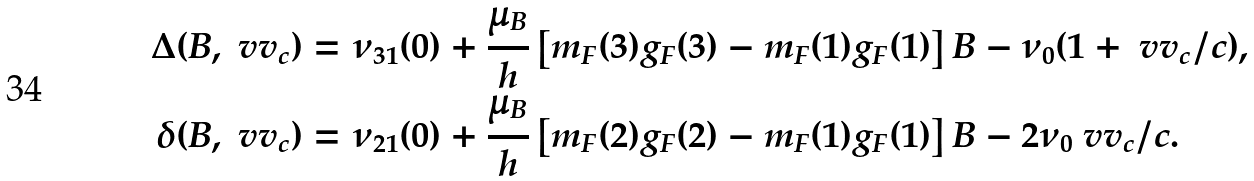Convert formula to latex. <formula><loc_0><loc_0><loc_500><loc_500>\Delta ( B , \ v v _ { c } ) & = \nu _ { 3 1 } ( 0 ) + \frac { \mu _ { B } } { h } \left [ m _ { F } ( 3 ) g _ { F } ( 3 ) - m _ { F } ( 1 ) g _ { F } ( 1 ) \right ] B - \nu _ { 0 } ( 1 + \ v v _ { c } / c ) , \\ \delta ( B , \ v v _ { c } ) & = \nu _ { 2 1 } ( 0 ) + \frac { \mu _ { B } } { h } \left [ m _ { F } ( 2 ) g _ { F } ( 2 ) - m _ { F } ( 1 ) g _ { F } ( 1 ) \right ] B - 2 \nu _ { 0 } \ v v _ { c } / c .</formula> 